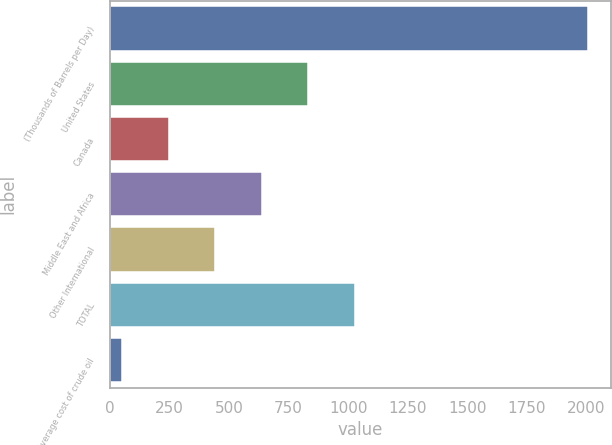Convert chart to OTSL. <chart><loc_0><loc_0><loc_500><loc_500><bar_chart><fcel>(Thousands of Barrels per Day)<fcel>United States<fcel>Canada<fcel>Middle East and Africa<fcel>Other International<fcel>TOTAL<fcel>Average cost of crude oil<nl><fcel>2005<fcel>833.12<fcel>247.17<fcel>637.81<fcel>442.49<fcel>1028.43<fcel>51.85<nl></chart> 